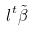<formula> <loc_0><loc_0><loc_500><loc_500>l ^ { t } \tilde { \beta }</formula> 